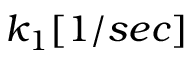Convert formula to latex. <formula><loc_0><loc_0><loc_500><loc_500>k _ { 1 } [ 1 / s e c ]</formula> 